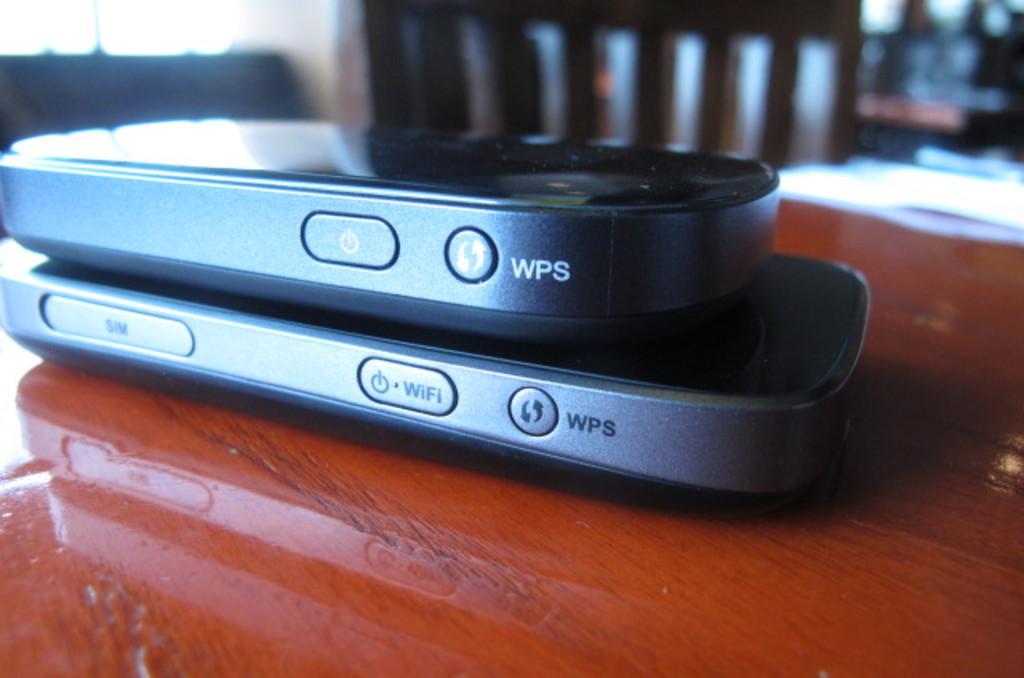What letters are written on both phones?
Offer a terse response. Wps. What is the button with the power say on it?
Your answer should be very brief. Wifi. 